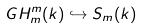<formula> <loc_0><loc_0><loc_500><loc_500>G H ^ { m } _ { m } ( k ) \hookrightarrow S _ { m } ( k )</formula> 